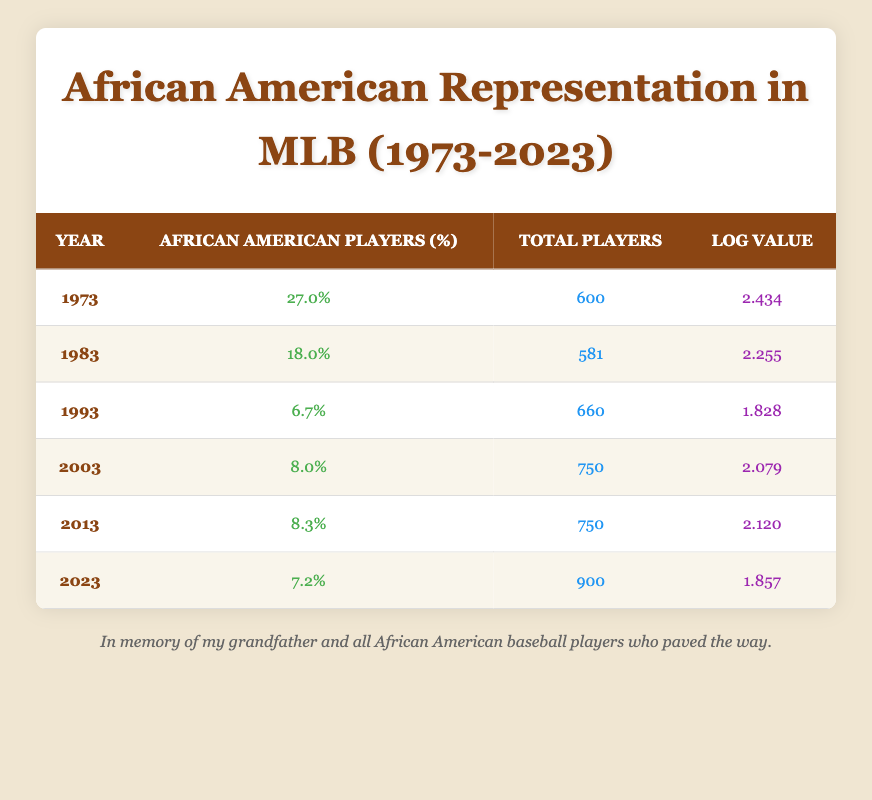What was the percentage of African American players in 1973? The table indicates that in 1973, the percentage of African American players was 27.0%.
Answer: 27.0% What is the total number of players in 2023? According to the table, the total number of players in 2023 is 900.
Answer: 900 What is the change in percentage of African American players from 1983 to 1993? In 1983, the percentage was 18.0%, and by 1993 it had decreased to 6.7%. The change is 18.0% - 6.7% = 11.3%.
Answer: 11.3% Is the log value for the year 2003 greater than that of 2013? The log value for 2003 is 2.079, while for 2013 it is 2.120. Since 2.079 is less than 2.120, the statement is false.
Answer: No What was the average percentage of African American players from 2003 to 2023? The percentages from 2003 to 2023 are 8.0%, 8.3%, and 7.2%. The average is calculated as (8.0% + 8.3% + 7.2%) / 3 = 7.83%.
Answer: 7.83% What is the total number of African American players in 1993 if there were 660 total players? To find the number of African American players in 1993, we take 6.7% of 660. This is calculated as 0.067 * 660 = 44.22, which rounds to approximately 44 players.
Answer: 44 In what year was the smallest percentage of African American players recorded? The smallest percentage in the table is 6.7%, recorded in 1993.
Answer: 1993 What can be inferred about the trend in representation of African American players from 1973 to 2023? The data shows a decline from a high of 27.0% in 1973 to a low of 7.2% in 2023, indicating a decreasing trend in representation over the 50-year span.
Answer: Decreasing trend 